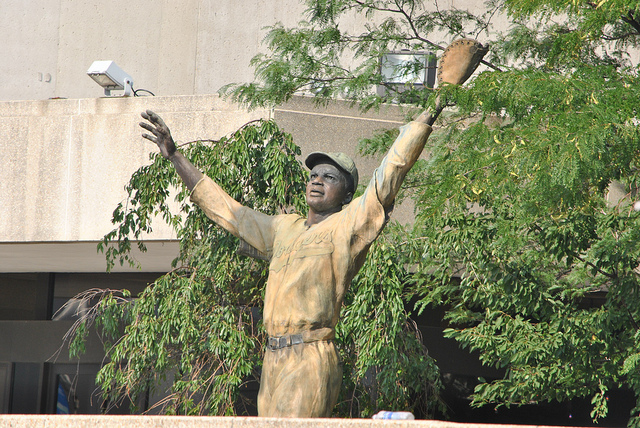<image>What are the different texture of the statue? I am not sure about the different textures of the statue. However, it can be rough, smooth, or resemble the texture of cloth or bronze. What are the different texture of the statue? I don't know the different textures of the statue. It can be smooth, rough, patina, cloth, or bronze. 